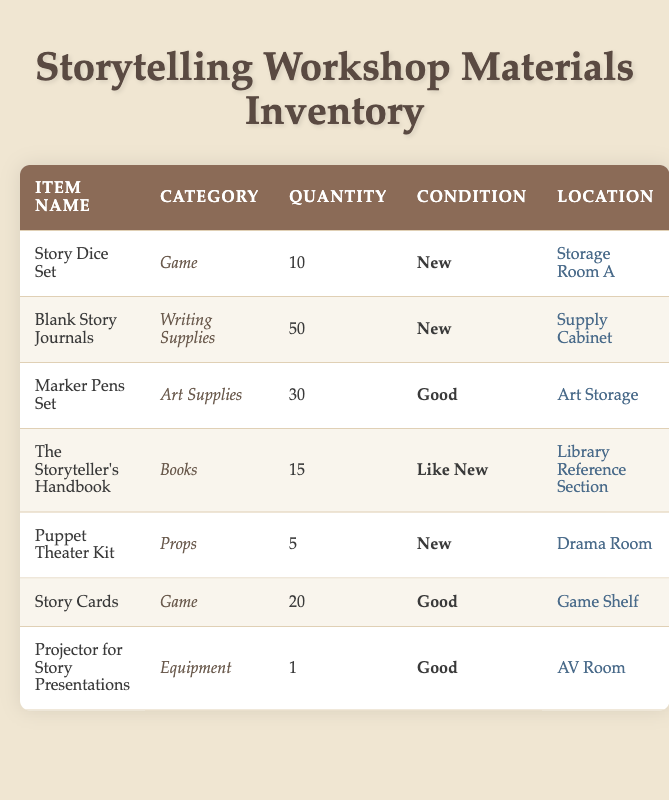What is the total number of Story Dice Sets available? The table indicates that there are 10 Story Dice Sets listed under the Quantity column for this item, so we simply refer to that cell.
Answer: 10 What category does the Puppet Theater Kit belong to? By locating the row for the Puppet Theater Kit, we can see that it falls under the Props category, as indicated in the table.
Answer: Props Are there more Blank Story Journals than Marker Pens Sets? The Quantity column shows 50 Blank Story Journals and 30 Marker Pens Sets. Since 50 is greater than 30, the answer is yes.
Answer: Yes How many items are listed under the Equipment category? The table shows one item under the Equipment category, which is the Projector for Story Presentations. We can verify this by analyzing the rows under the category column.
Answer: 1 What is the combined quantity of Story Cards and Puppet Theater Kits? To find the combined quantity, we add the quantities together: 20 Story Cards + 5 Puppet Theater Kits = 25. Hence, we see the result is 25.
Answer: 25 Is The Storyteller's Handbook in good condition? The condition listed for The Storyteller's Handbook is "Like New." Since "Good" would suggest a better state, the answer is no.
Answer: No Which location has the highest quantity of materials? The highest quantity is found in the Supply Cabinet with 50 Blank Story Journals. This involves checking the Quantity column and matching it to the respective Location.
Answer: Supply Cabinet What percentage of the total quantity of all materials is comprised of the Blank Story Journals? First, we calculate the total quantity of all items: 10 + 50 + 30 + 15 + 5 + 20 + 1 = 131. Then, we find the percentage of Blank Story Journals: (50 / 131) * 100 ≈ 38.17%. So, the percentage is approximately 38.17%.
Answer: 38.17% How many items are there in "Good" condition? From the table, we see three items listed as "Good": Marker Pens Set, Story Cards, and Projector for Story Presentations. So, the total count is three.
Answer: 3 